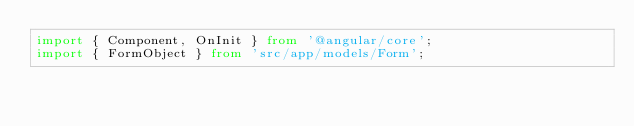<code> <loc_0><loc_0><loc_500><loc_500><_TypeScript_>import { Component, OnInit } from '@angular/core';
import { FormObject } from 'src/app/models/Form';</code> 